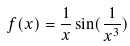Convert formula to latex. <formula><loc_0><loc_0><loc_500><loc_500>f ( x ) = \frac { 1 } { x } \sin ( \frac { 1 } { x ^ { 3 } } )</formula> 